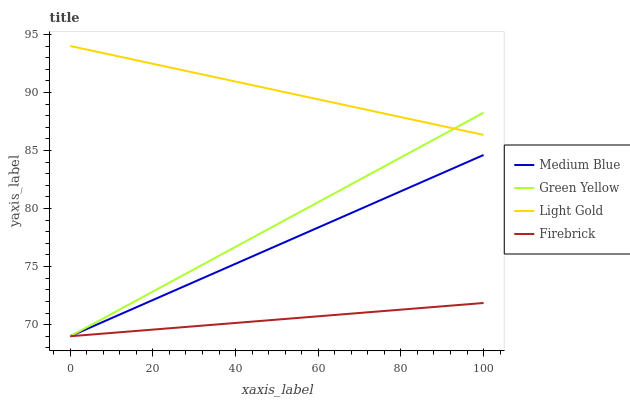Does Firebrick have the minimum area under the curve?
Answer yes or no. Yes. Does Light Gold have the maximum area under the curve?
Answer yes or no. Yes. Does Green Yellow have the minimum area under the curve?
Answer yes or no. No. Does Green Yellow have the maximum area under the curve?
Answer yes or no. No. Is Firebrick the smoothest?
Answer yes or no. Yes. Is Light Gold the roughest?
Answer yes or no. Yes. Is Green Yellow the smoothest?
Answer yes or no. No. Is Green Yellow the roughest?
Answer yes or no. No. Does Firebrick have the lowest value?
Answer yes or no. Yes. Does Light Gold have the highest value?
Answer yes or no. Yes. Does Green Yellow have the highest value?
Answer yes or no. No. Is Medium Blue less than Light Gold?
Answer yes or no. Yes. Is Light Gold greater than Firebrick?
Answer yes or no. Yes. Does Green Yellow intersect Light Gold?
Answer yes or no. Yes. Is Green Yellow less than Light Gold?
Answer yes or no. No. Is Green Yellow greater than Light Gold?
Answer yes or no. No. Does Medium Blue intersect Light Gold?
Answer yes or no. No. 